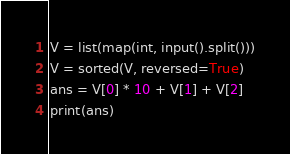Convert code to text. <code><loc_0><loc_0><loc_500><loc_500><_Python_>V = list(map(int, input().split()))
V = sorted(V, reversed=True)
ans = V[0] * 10 + V[1] + V[2]
print(ans)</code> 